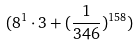<formula> <loc_0><loc_0><loc_500><loc_500>( 8 ^ { 1 } \cdot 3 + ( \frac { 1 } { 3 4 6 } ) ^ { 1 5 8 } )</formula> 